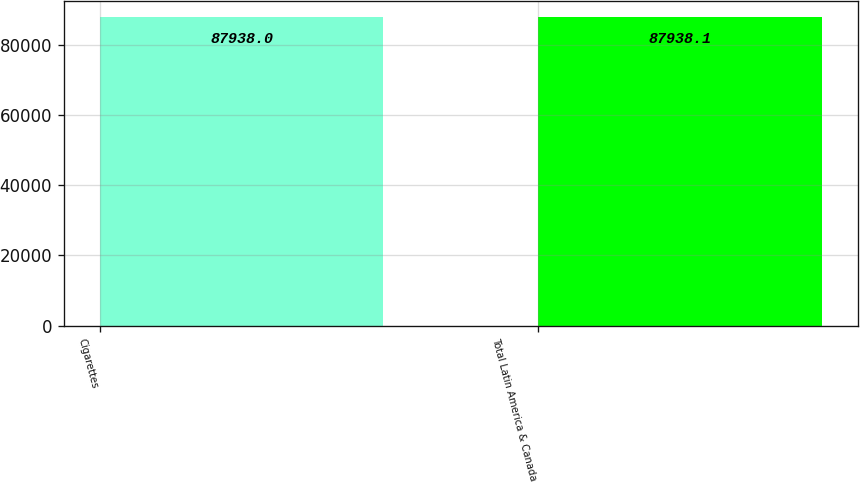Convert chart to OTSL. <chart><loc_0><loc_0><loc_500><loc_500><bar_chart><fcel>Cigarettes<fcel>Total Latin America & Canada<nl><fcel>87938<fcel>87938.1<nl></chart> 